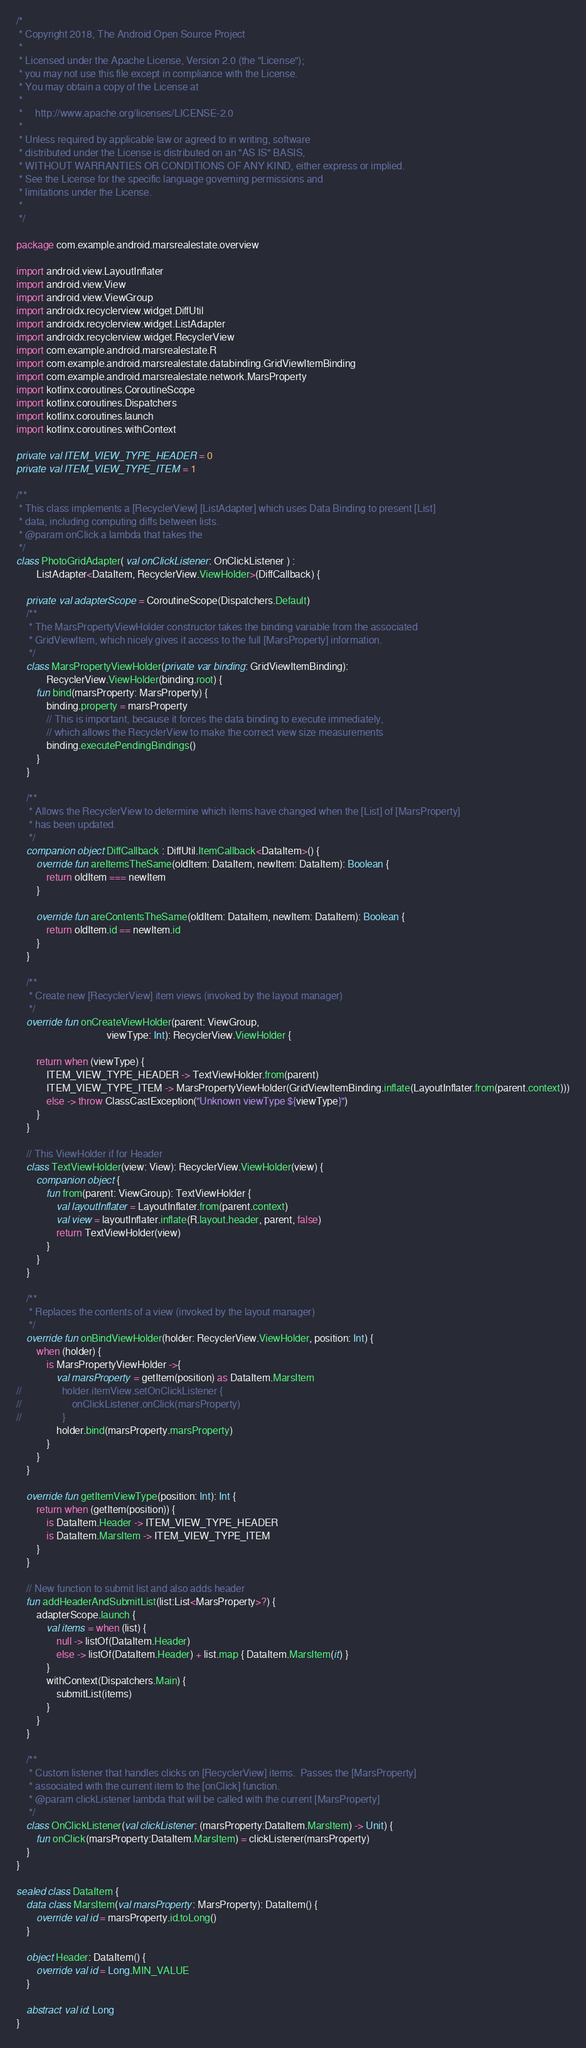Convert code to text. <code><loc_0><loc_0><loc_500><loc_500><_Kotlin_>/*
 * Copyright 2018, The Android Open Source Project
 *
 * Licensed under the Apache License, Version 2.0 (the "License");
 * you may not use this file except in compliance with the License.
 * You may obtain a copy of the License at
 *
 *     http://www.apache.org/licenses/LICENSE-2.0
 *
 * Unless required by applicable law or agreed to in writing, software
 * distributed under the License is distributed on an "AS IS" BASIS,
 * WITHOUT WARRANTIES OR CONDITIONS OF ANY KIND, either express or implied.
 * See the License for the specific language governing permissions and
 * limitations under the License.
 *
 */

package com.example.android.marsrealestate.overview

import android.view.LayoutInflater
import android.view.View
import android.view.ViewGroup
import androidx.recyclerview.widget.DiffUtil
import androidx.recyclerview.widget.ListAdapter
import androidx.recyclerview.widget.RecyclerView
import com.example.android.marsrealestate.R
import com.example.android.marsrealestate.databinding.GridViewItemBinding
import com.example.android.marsrealestate.network.MarsProperty
import kotlinx.coroutines.CoroutineScope
import kotlinx.coroutines.Dispatchers
import kotlinx.coroutines.launch
import kotlinx.coroutines.withContext

private val ITEM_VIEW_TYPE_HEADER = 0
private val ITEM_VIEW_TYPE_ITEM = 1

/**
 * This class implements a [RecyclerView] [ListAdapter] which uses Data Binding to present [List]
 * data, including computing diffs between lists.
 * @param onClick a lambda that takes the
 */
class PhotoGridAdapter( val onClickListener: OnClickListener ) :
        ListAdapter<DataItem, RecyclerView.ViewHolder>(DiffCallback) {

    private val adapterScope = CoroutineScope(Dispatchers.Default)
    /**
     * The MarsPropertyViewHolder constructor takes the binding variable from the associated
     * GridViewItem, which nicely gives it access to the full [MarsProperty] information.
     */
    class MarsPropertyViewHolder(private var binding: GridViewItemBinding):
            RecyclerView.ViewHolder(binding.root) {
        fun bind(marsProperty: MarsProperty) {
            binding.property = marsProperty
            // This is important, because it forces the data binding to execute immediately,
            // which allows the RecyclerView to make the correct view size measurements
            binding.executePendingBindings()
        }
    }

    /**
     * Allows the RecyclerView to determine which items have changed when the [List] of [MarsProperty]
     * has been updated.
     */
    companion object DiffCallback : DiffUtil.ItemCallback<DataItem>() {
        override fun areItemsTheSame(oldItem: DataItem, newItem: DataItem): Boolean {
            return oldItem === newItem
        }

        override fun areContentsTheSame(oldItem: DataItem, newItem: DataItem): Boolean {
            return oldItem.id == newItem.id
        }
    }

    /**
     * Create new [RecyclerView] item views (invoked by the layout manager)
     */
    override fun onCreateViewHolder(parent: ViewGroup,
                                    viewType: Int): RecyclerView.ViewHolder {

        return when (viewType) {
            ITEM_VIEW_TYPE_HEADER -> TextViewHolder.from(parent)
            ITEM_VIEW_TYPE_ITEM -> MarsPropertyViewHolder(GridViewItemBinding.inflate(LayoutInflater.from(parent.context)))
            else -> throw ClassCastException("Unknown viewType ${viewType}")
        }
    }

    // This ViewHolder if for Header
    class TextViewHolder(view: View): RecyclerView.ViewHolder(view) {
        companion object {
            fun from(parent: ViewGroup): TextViewHolder {
                val layoutInflater = LayoutInflater.from(parent.context)
                val view = layoutInflater.inflate(R.layout.header, parent, false)
                return TextViewHolder(view)
            }
        }
    }

    /**
     * Replaces the contents of a view (invoked by the layout manager)
     */
    override fun onBindViewHolder(holder: RecyclerView.ViewHolder, position: Int) {
        when (holder) {
            is MarsPropertyViewHolder ->{
                val marsProperty = getItem(position) as DataItem.MarsItem
//                holder.itemView.setOnClickListener {
//                    onClickListener.onClick(marsProperty)
//                }
                holder.bind(marsProperty.marsProperty)
            }
        }
    }

    override fun getItemViewType(position: Int): Int {
        return when (getItem(position)) {
            is DataItem.Header -> ITEM_VIEW_TYPE_HEADER
            is DataItem.MarsItem -> ITEM_VIEW_TYPE_ITEM
        }
    }

    // New function to submit list and also adds header
    fun addHeaderAndSubmitList(list:List<MarsProperty>?) {
        adapterScope.launch {
            val items = when (list) {
                null -> listOf(DataItem.Header)
                else -> listOf(DataItem.Header) + list.map { DataItem.MarsItem(it) }
            }
            withContext(Dispatchers.Main) {
                submitList(items)
            }
        }
    }

    /**
     * Custom listener that handles clicks on [RecyclerView] items.  Passes the [MarsProperty]
     * associated with the current item to the [onClick] function.
     * @param clickListener lambda that will be called with the current [MarsProperty]
     */
    class OnClickListener(val clickListener: (marsProperty:DataItem.MarsItem) -> Unit) {
        fun onClick(marsProperty:DataItem.MarsItem) = clickListener(marsProperty)
    }
}

sealed class DataItem {
    data class MarsItem(val marsProperty: MarsProperty): DataItem() {
        override val id = marsProperty.id.toLong()
    }

    object Header: DataItem() {
        override val id = Long.MIN_VALUE
    }

    abstract val id: Long
}
</code> 